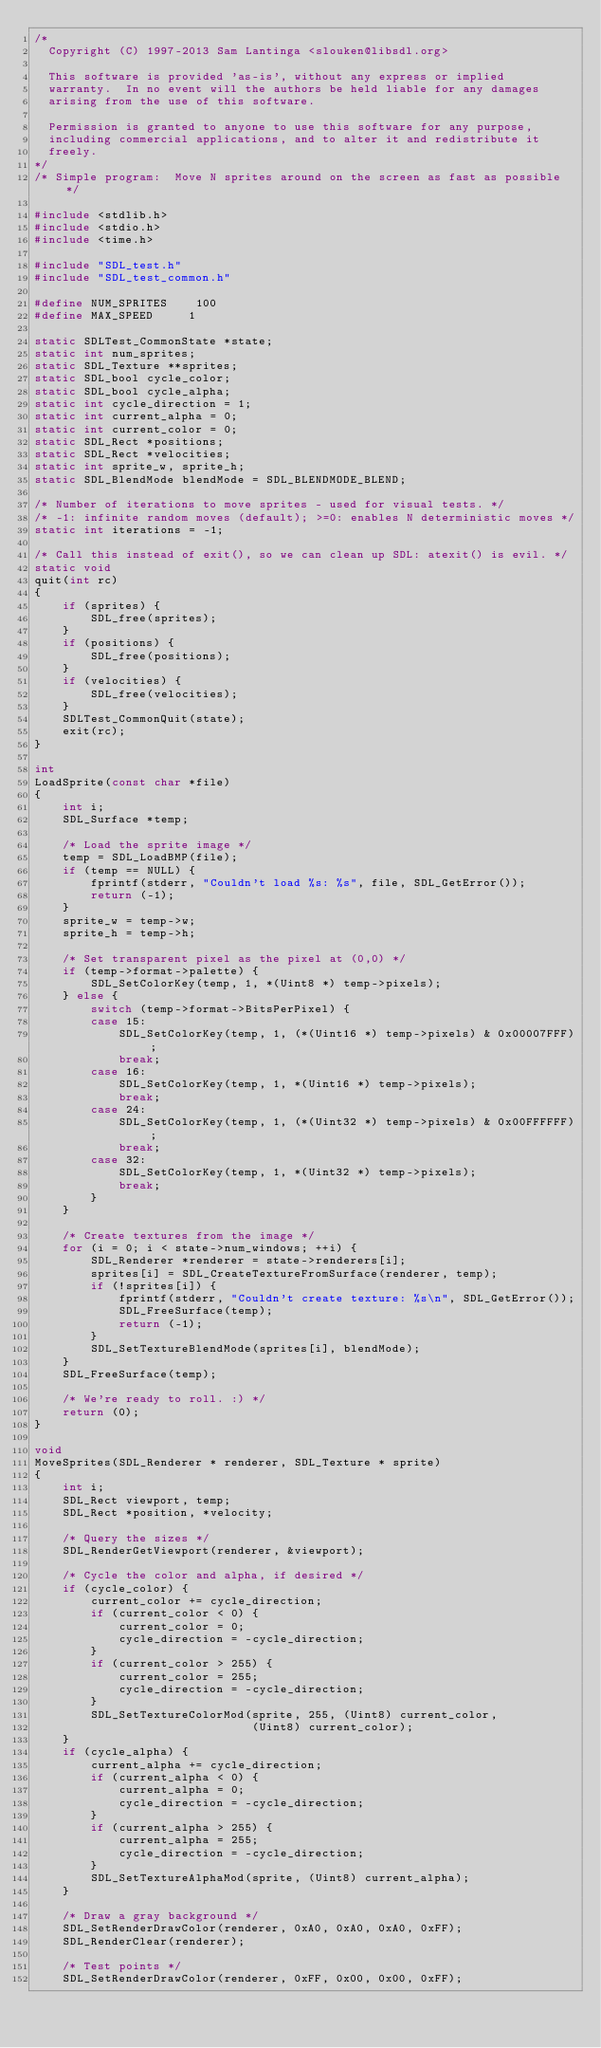<code> <loc_0><loc_0><loc_500><loc_500><_C_>/*
  Copyright (C) 1997-2013 Sam Lantinga <slouken@libsdl.org>

  This software is provided 'as-is', without any express or implied
  warranty.  In no event will the authors be held liable for any damages
  arising from the use of this software.

  Permission is granted to anyone to use this software for any purpose,
  including commercial applications, and to alter it and redistribute it
  freely.
*/
/* Simple program:  Move N sprites around on the screen as fast as possible */

#include <stdlib.h>
#include <stdio.h>
#include <time.h>

#include "SDL_test.h"
#include "SDL_test_common.h"

#define NUM_SPRITES    100
#define MAX_SPEED     1

static SDLTest_CommonState *state;
static int num_sprites;
static SDL_Texture **sprites;
static SDL_bool cycle_color;
static SDL_bool cycle_alpha;
static int cycle_direction = 1;
static int current_alpha = 0;
static int current_color = 0;
static SDL_Rect *positions;
static SDL_Rect *velocities;
static int sprite_w, sprite_h;
static SDL_BlendMode blendMode = SDL_BLENDMODE_BLEND;

/* Number of iterations to move sprites - used for visual tests. */
/* -1: infinite random moves (default); >=0: enables N deterministic moves */
static int iterations = -1;

/* Call this instead of exit(), so we can clean up SDL: atexit() is evil. */
static void
quit(int rc)
{
    if (sprites) {
        SDL_free(sprites);
    }
    if (positions) {
        SDL_free(positions);
    }
    if (velocities) {
        SDL_free(velocities);
    }
    SDLTest_CommonQuit(state);
    exit(rc);
}

int
LoadSprite(const char *file)
{
    int i;
    SDL_Surface *temp;

    /* Load the sprite image */
    temp = SDL_LoadBMP(file);
    if (temp == NULL) {
        fprintf(stderr, "Couldn't load %s: %s", file, SDL_GetError());
        return (-1);
    }
    sprite_w = temp->w;
    sprite_h = temp->h;

    /* Set transparent pixel as the pixel at (0,0) */
    if (temp->format->palette) {
        SDL_SetColorKey(temp, 1, *(Uint8 *) temp->pixels);
    } else {
        switch (temp->format->BitsPerPixel) {
        case 15:
            SDL_SetColorKey(temp, 1, (*(Uint16 *) temp->pixels) & 0x00007FFF);
            break;
        case 16:
            SDL_SetColorKey(temp, 1, *(Uint16 *) temp->pixels);
            break;
        case 24:
            SDL_SetColorKey(temp, 1, (*(Uint32 *) temp->pixels) & 0x00FFFFFF);
            break;
        case 32:
            SDL_SetColorKey(temp, 1, *(Uint32 *) temp->pixels);
            break;
        }
    }

    /* Create textures from the image */
    for (i = 0; i < state->num_windows; ++i) {
        SDL_Renderer *renderer = state->renderers[i];
        sprites[i] = SDL_CreateTextureFromSurface(renderer, temp);
        if (!sprites[i]) {
            fprintf(stderr, "Couldn't create texture: %s\n", SDL_GetError());
            SDL_FreeSurface(temp);
            return (-1);
        }
        SDL_SetTextureBlendMode(sprites[i], blendMode);
    }
    SDL_FreeSurface(temp);

    /* We're ready to roll. :) */
    return (0);
}

void
MoveSprites(SDL_Renderer * renderer, SDL_Texture * sprite)
{
    int i;
    SDL_Rect viewport, temp;
    SDL_Rect *position, *velocity;

    /* Query the sizes */
    SDL_RenderGetViewport(renderer, &viewport);

    /* Cycle the color and alpha, if desired */
    if (cycle_color) {
        current_color += cycle_direction;
        if (current_color < 0) {
            current_color = 0;
            cycle_direction = -cycle_direction;
        }
        if (current_color > 255) {
            current_color = 255;
            cycle_direction = -cycle_direction;
        }
        SDL_SetTextureColorMod(sprite, 255, (Uint8) current_color,
                               (Uint8) current_color);
    }
    if (cycle_alpha) {
        current_alpha += cycle_direction;
        if (current_alpha < 0) {
            current_alpha = 0;
            cycle_direction = -cycle_direction;
        }
        if (current_alpha > 255) {
            current_alpha = 255;
            cycle_direction = -cycle_direction;
        }
        SDL_SetTextureAlphaMod(sprite, (Uint8) current_alpha);
    }

    /* Draw a gray background */
    SDL_SetRenderDrawColor(renderer, 0xA0, 0xA0, 0xA0, 0xFF);
    SDL_RenderClear(renderer);

    /* Test points */
    SDL_SetRenderDrawColor(renderer, 0xFF, 0x00, 0x00, 0xFF);</code> 